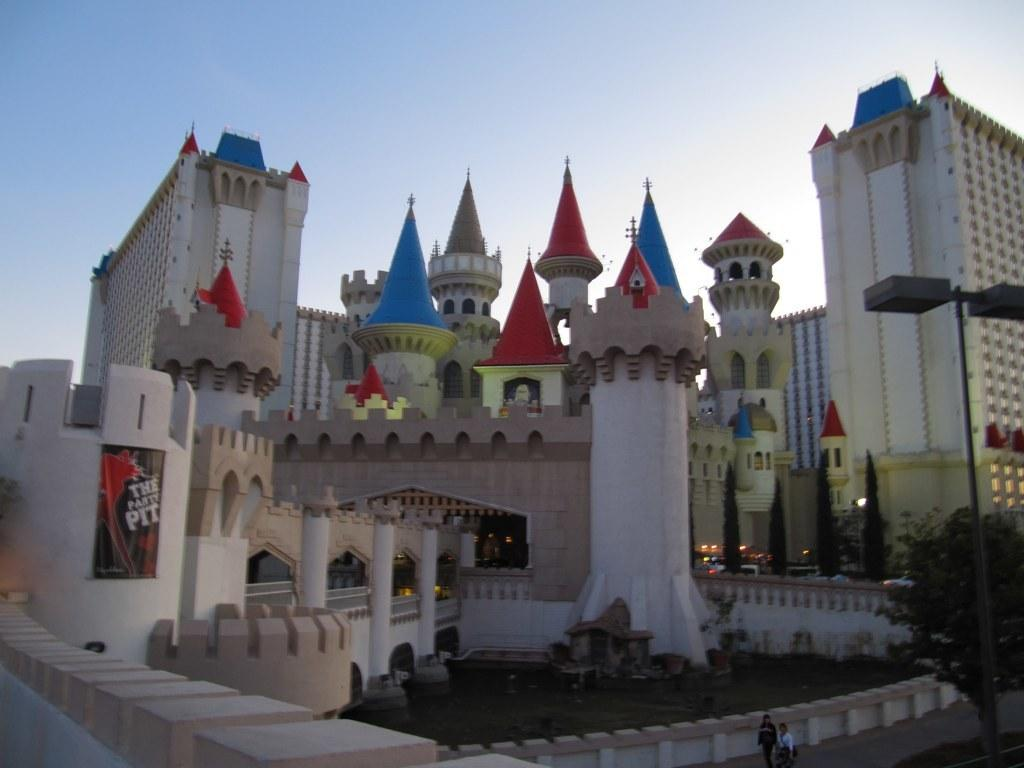What type of structures are present in the image? There are castles in the image. How many people can be seen in the image? There are two persons standing in the image. What type of natural elements are present in the image? There are trees in the image. What type of illumination is present in the image? There are lights in the image. What type of decorative element is present in the image? There is a banner in the image. What can be seen in the background of the image? The sky is visible in the background of the image. What type of verse can be heard recited by the person standing near the dock in the image? There is no dock or person reciting a verse present in the image. What type of expansion is visible on the castles in the image? The image does not show any expansions on the castles; they appear to be complete structures. 